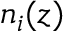<formula> <loc_0><loc_0><loc_500><loc_500>n _ { i } ( z )</formula> 